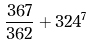<formula> <loc_0><loc_0><loc_500><loc_500>\frac { 3 6 7 } { 3 6 2 } + 3 2 4 ^ { 7 }</formula> 